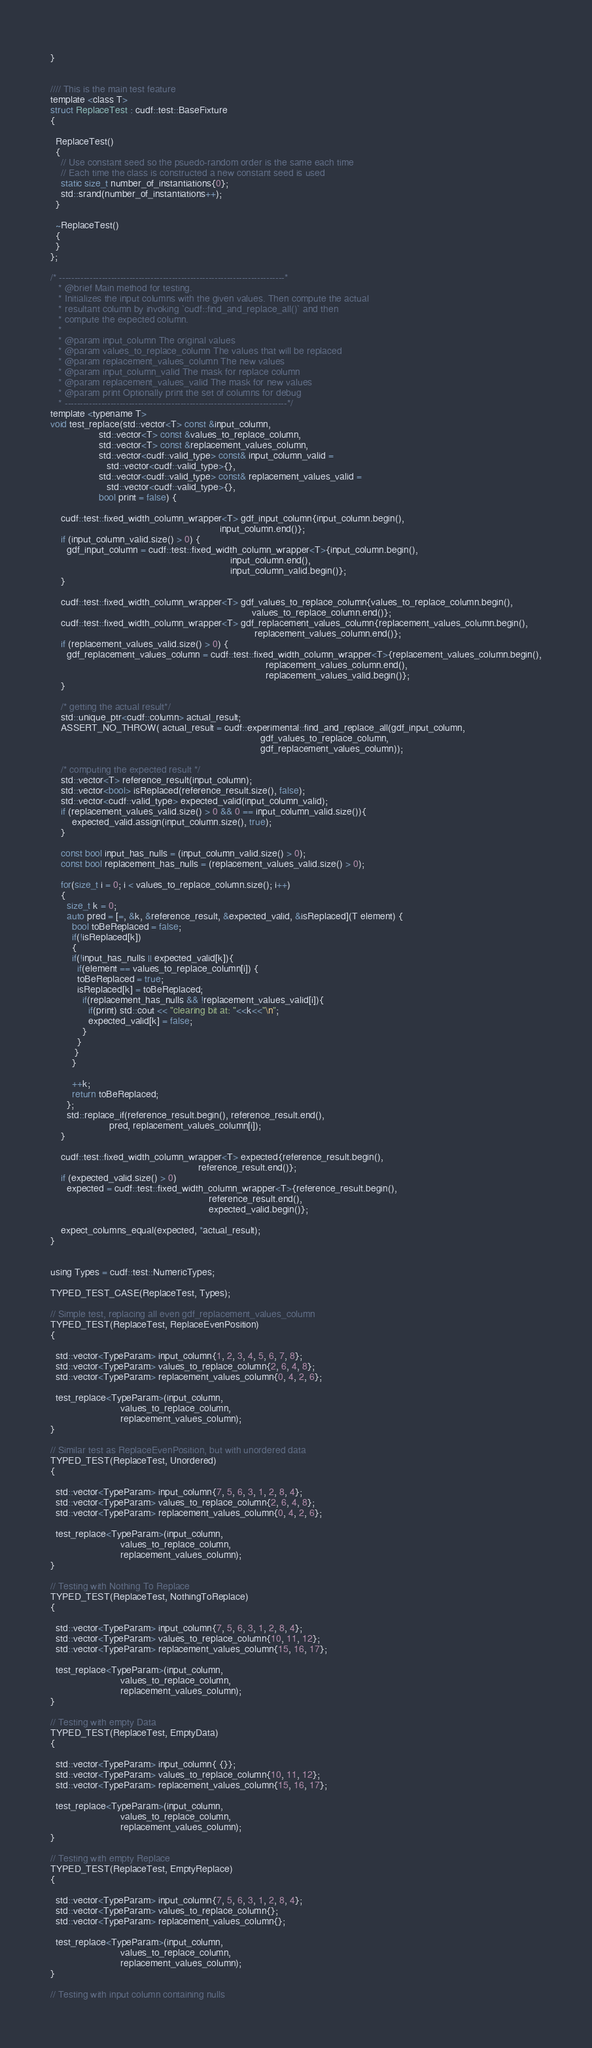<code> <loc_0><loc_0><loc_500><loc_500><_Cuda_>}


//// This is the main test feature
template <class T>
struct ReplaceTest : cudf::test::BaseFixture
{

  ReplaceTest()
  {
    // Use constant seed so the psuedo-random order is the same each time
    // Each time the class is constructed a new constant seed is used
    static size_t number_of_instantiations{0};
    std::srand(number_of_instantiations++);
  }

  ~ReplaceTest()
  {
  }
};

/* --------------------------------------------------------------------------*
   * @brief Main method for testing.
   * Initializes the input columns with the given values. Then compute the actual
   * resultant column by invoking `cudf::find_and_replace_all()` and then
   * compute the expected column.
   *
   * @param input_column The original values
   * @param values_to_replace_column The values that will be replaced
   * @param replacement_values_column The new values
   * @param input_column_valid The mask for replace column
   * @param replacement_values_valid The mask for new values
   * @param print Optionally print the set of columns for debug
   * -------------------------------------------------------------------------*/
template <typename T>
void test_replace(std::vector<T> const &input_column,
                  std::vector<T> const &values_to_replace_column,
                  std::vector<T> const &replacement_values_column,
                  std::vector<cudf::valid_type> const& input_column_valid =
                     std::vector<cudf::valid_type>{},
                  std::vector<cudf::valid_type> const& replacement_values_valid =
                     std::vector<cudf::valid_type>{},
                  bool print = false) {

    cudf::test::fixed_width_column_wrapper<T> gdf_input_column{input_column.begin(),
                                                               input_column.end()};
    if (input_column_valid.size() > 0) {
      gdf_input_column = cudf::test::fixed_width_column_wrapper<T>{input_column.begin(),
                                                                   input_column.end(),
                                                                   input_column_valid.begin()};
    }

    cudf::test::fixed_width_column_wrapper<T> gdf_values_to_replace_column{values_to_replace_column.begin(),
                                                                           values_to_replace_column.end()};
    cudf::test::fixed_width_column_wrapper<T> gdf_replacement_values_column{replacement_values_column.begin(),
                                                                            replacement_values_column.end()};
    if (replacement_values_valid.size() > 0) {
      gdf_replacement_values_column = cudf::test::fixed_width_column_wrapper<T>{replacement_values_column.begin(),
                                                                                replacement_values_column.end(),
                                                                                replacement_values_valid.begin()};
    }

    /* getting the actual result*/
    std::unique_ptr<cudf::column> actual_result;
    ASSERT_NO_THROW( actual_result = cudf::experimental::find_and_replace_all(gdf_input_column,
                                                                              gdf_values_to_replace_column,
                                                                              gdf_replacement_values_column));

    /* computing the expected result */
    std::vector<T> reference_result(input_column);
    std::vector<bool> isReplaced(reference_result.size(), false);
    std::vector<cudf::valid_type> expected_valid(input_column_valid);
    if (replacement_values_valid.size() > 0 && 0 == input_column_valid.size()){
        expected_valid.assign(input_column.size(), true);
    }

    const bool input_has_nulls = (input_column_valid.size() > 0);
    const bool replacement_has_nulls = (replacement_values_valid.size() > 0);

    for(size_t i = 0; i < values_to_replace_column.size(); i++)
    {
      size_t k = 0;
      auto pred = [=, &k, &reference_result, &expected_valid, &isReplaced](T element) {
        bool toBeReplaced = false;
        if(!isReplaced[k])
        {
        if(!input_has_nulls || expected_valid[k]){
          if(element == values_to_replace_column[i]) {
          toBeReplaced = true;
          isReplaced[k] = toBeReplaced;
            if(replacement_has_nulls && !replacement_values_valid[i]){
              if(print) std::cout << "clearing bit at: "<<k<<"\n";
              expected_valid[k] = false;
            }
          }
         }
        }

        ++k;
        return toBeReplaced;
      };
      std::replace_if(reference_result.begin(), reference_result.end(),
                      pred, replacement_values_column[i]);
    }

    cudf::test::fixed_width_column_wrapper<T> expected{reference_result.begin(),
                                                       reference_result.end()};
    if (expected_valid.size() > 0)
      expected = cudf::test::fixed_width_column_wrapper<T>{reference_result.begin(),
                                                           reference_result.end(),
                                                           expected_valid.begin()};

    expect_columns_equal(expected, *actual_result);
}


using Types = cudf::test::NumericTypes;

TYPED_TEST_CASE(ReplaceTest, Types);

// Simple test, replacing all even gdf_replacement_values_column
TYPED_TEST(ReplaceTest, ReplaceEvenPosition)
{

  std::vector<TypeParam> input_column{1, 2, 3, 4, 5, 6, 7, 8};
  std::vector<TypeParam> values_to_replace_column{2, 6, 4, 8};
  std::vector<TypeParam> replacement_values_column{0, 4, 2, 6};

  test_replace<TypeParam>(input_column,
                          values_to_replace_column,
                          replacement_values_column);
}

// Similar test as ReplaceEvenPosition, but with unordered data
TYPED_TEST(ReplaceTest, Unordered)
{

  std::vector<TypeParam> input_column{7, 5, 6, 3, 1, 2, 8, 4};
  std::vector<TypeParam> values_to_replace_column{2, 6, 4, 8};
  std::vector<TypeParam> replacement_values_column{0, 4, 2, 6};

  test_replace<TypeParam>(input_column,
                          values_to_replace_column,
                          replacement_values_column);
}

// Testing with Nothing To Replace
TYPED_TEST(ReplaceTest, NothingToReplace)
{

  std::vector<TypeParam> input_column{7, 5, 6, 3, 1, 2, 8, 4};
  std::vector<TypeParam> values_to_replace_column{10, 11, 12};
  std::vector<TypeParam> replacement_values_column{15, 16, 17};

  test_replace<TypeParam>(input_column,
                          values_to_replace_column,
                          replacement_values_column);
}

// Testing with empty Data
TYPED_TEST(ReplaceTest, EmptyData)
{

  std::vector<TypeParam> input_column{ {}};
  std::vector<TypeParam> values_to_replace_column{10, 11, 12};
  std::vector<TypeParam> replacement_values_column{15, 16, 17};

  test_replace<TypeParam>(input_column,
                          values_to_replace_column,
                          replacement_values_column);
}

// Testing with empty Replace
TYPED_TEST(ReplaceTest, EmptyReplace)
{

  std::vector<TypeParam> input_column{7, 5, 6, 3, 1, 2, 8, 4};
  std::vector<TypeParam> values_to_replace_column{};
  std::vector<TypeParam> replacement_values_column{};

  test_replace<TypeParam>(input_column,
                          values_to_replace_column,
                          replacement_values_column);
}

// Testing with input column containing nulls</code> 